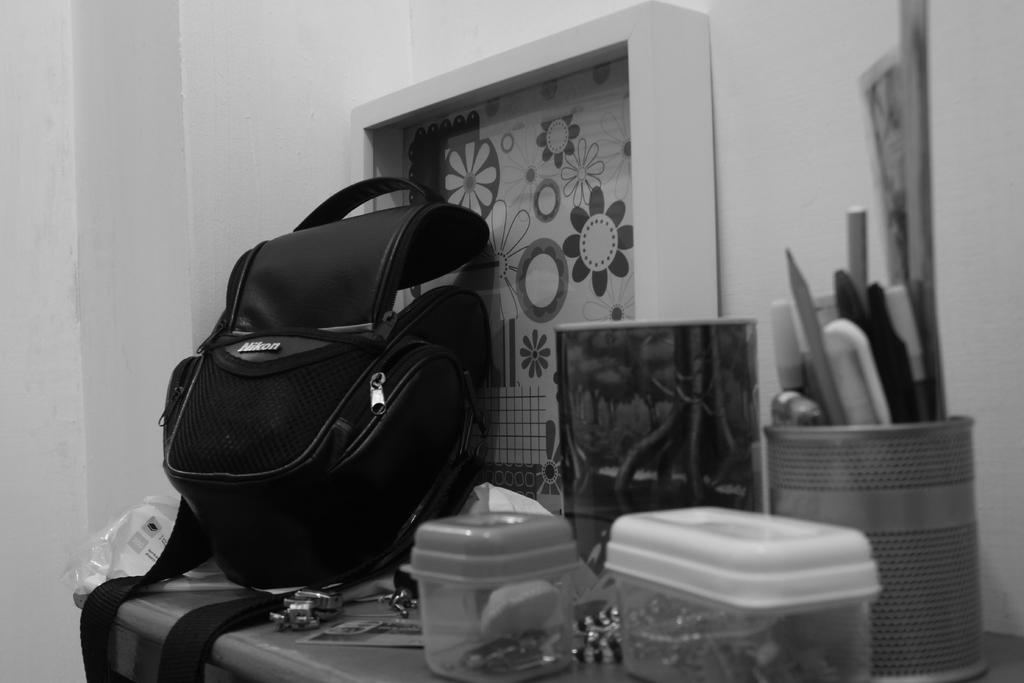What is on the table in the image? There is a bag, boxes, and a plastic cover on the table. Are there any other items on the table? Yes, there are other things on the table. What can be seen in the background of the image? There is a wall visible in the image. How does the son help with the wire in the image? There is no son or wire present in the image. 